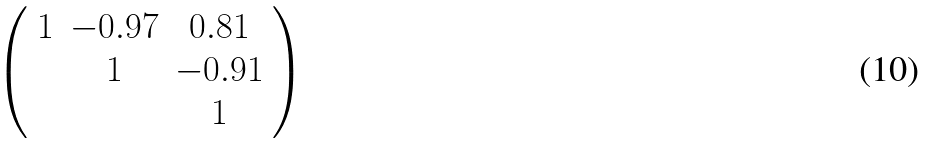<formula> <loc_0><loc_0><loc_500><loc_500>\left ( \begin{array} { c c c } 1 & - 0 . 9 7 & 0 . 8 1 \\ & 1 & - 0 . 9 1 \\ & & 1 \\ \end{array} \right )</formula> 